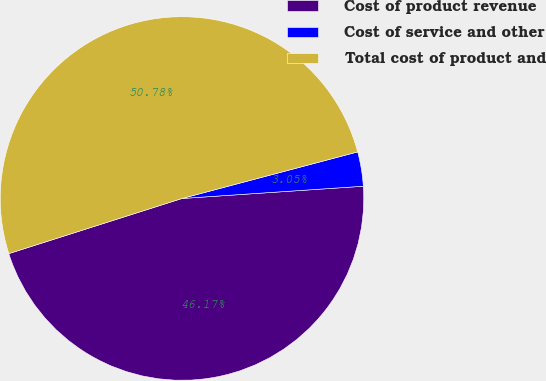Convert chart to OTSL. <chart><loc_0><loc_0><loc_500><loc_500><pie_chart><fcel>Cost of product revenue<fcel>Cost of service and other<fcel>Total cost of product and<nl><fcel>46.17%<fcel>3.05%<fcel>50.78%<nl></chart> 